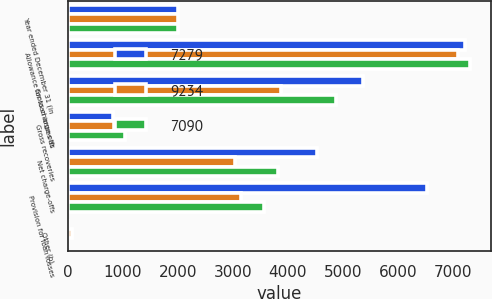Convert chart. <chart><loc_0><loc_0><loc_500><loc_500><stacked_bar_chart><ecel><fcel>Year ended December 31 (in<fcel>Allowance for loan losses at<fcel>Gross charge-offs<fcel>Gross recoveries<fcel>Net charge-offs<fcel>Provision for loan losses<fcel>Other (b)<nl><fcel>7279<fcel>2007<fcel>7223<fcel>5367<fcel>829<fcel>4538<fcel>6538<fcel>11<nl><fcel>9234<fcel>2006<fcel>7090<fcel>3884<fcel>842<fcel>3042<fcel>3153<fcel>78<nl><fcel>7090<fcel>2005<fcel>7320<fcel>4869<fcel>1050<fcel>3819<fcel>3575<fcel>14<nl></chart> 